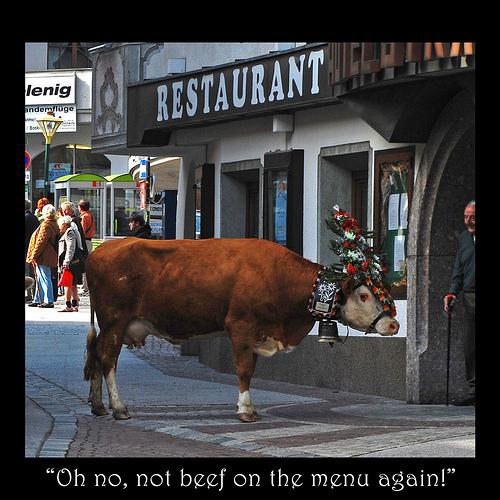What is around the cow's neck?
Write a very short answer. Bell. Is this a delivery milk cow?
Write a very short answer. No. Why is the caption humorous?
Quick response, please. Cow doesn't want to be eaten. 